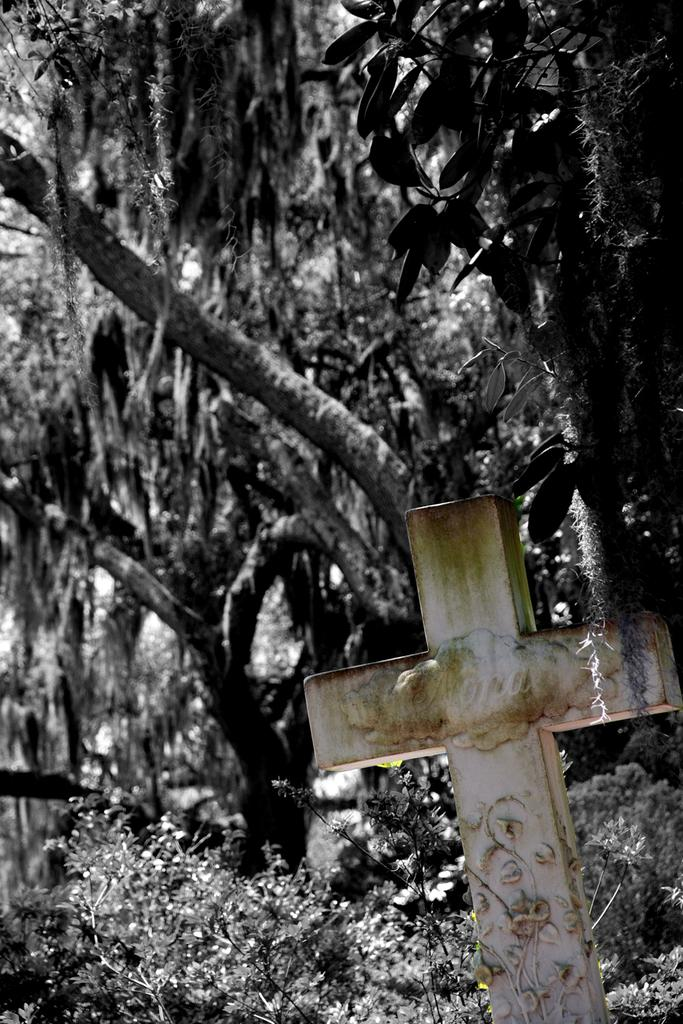What religious symbol is located on the right side of the image? There is a cross on the right side of the image. What can be seen in the distance in the image? There are trees in the background of the image. What type of vegetation is present on the ground in the background of the image? There are plants on the ground in the background of the image. What color scheme is used in the image? The image is black and white. How many beads are hanging from the cross in the image? There are no beads hanging from the cross in the image; it is a simple black and white cross. What type of match is depicted in the image? There is no match present in the image. 